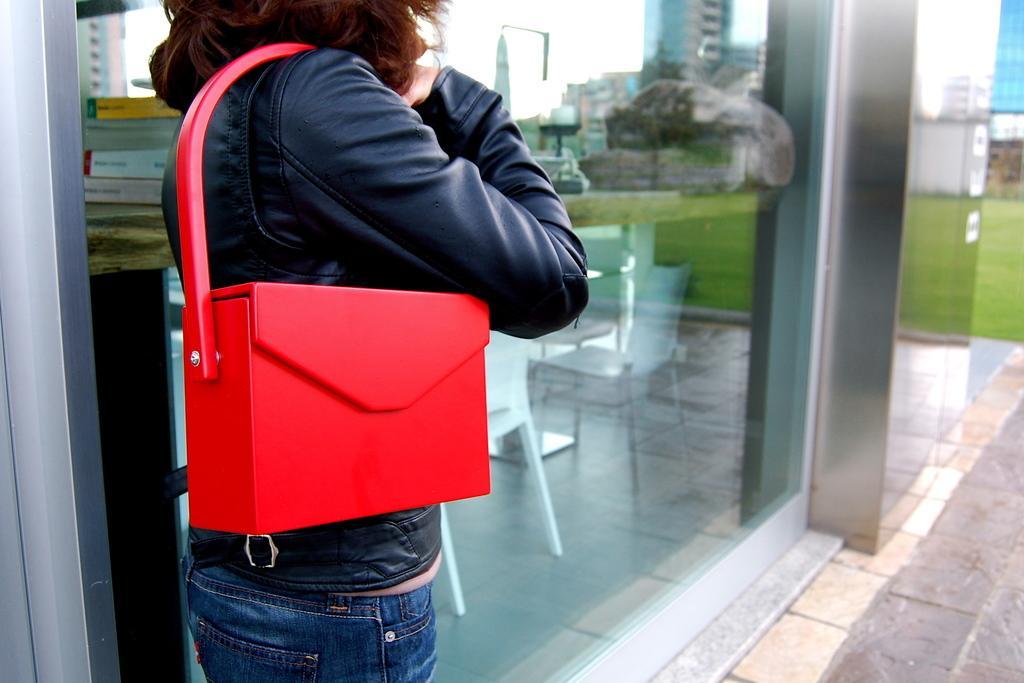How would you summarize this image in a sentence or two? In this picture there is a person standing in the foreground. At the back there are chairs behind the mirror and there are reflections of buildings and there is a reflection of tree, sky and grass on the mirror. On the right side of the image there is a building. At the bottom there is grass and there is a floor. 